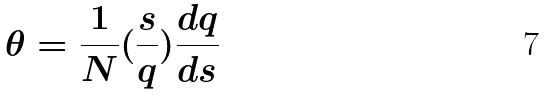Convert formula to latex. <formula><loc_0><loc_0><loc_500><loc_500>\theta = \frac { 1 } { N } ( \frac { s } { q } ) \frac { d q } { d s }</formula> 